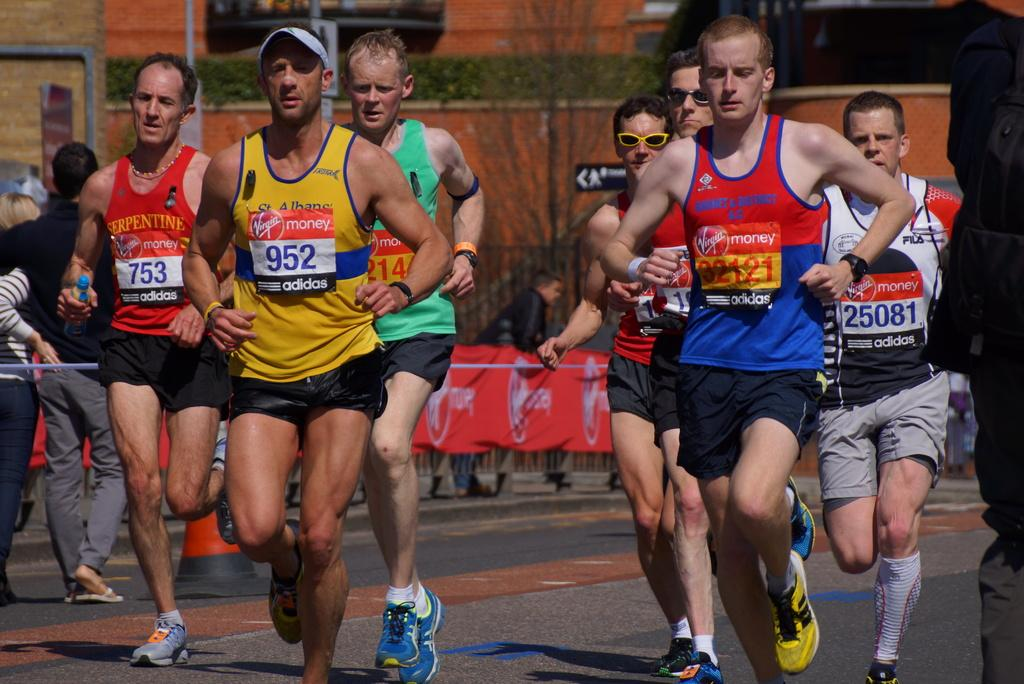<image>
Create a compact narrative representing the image presented. A man wearing yellow tank top with the number 952 is leading a group of runners. 